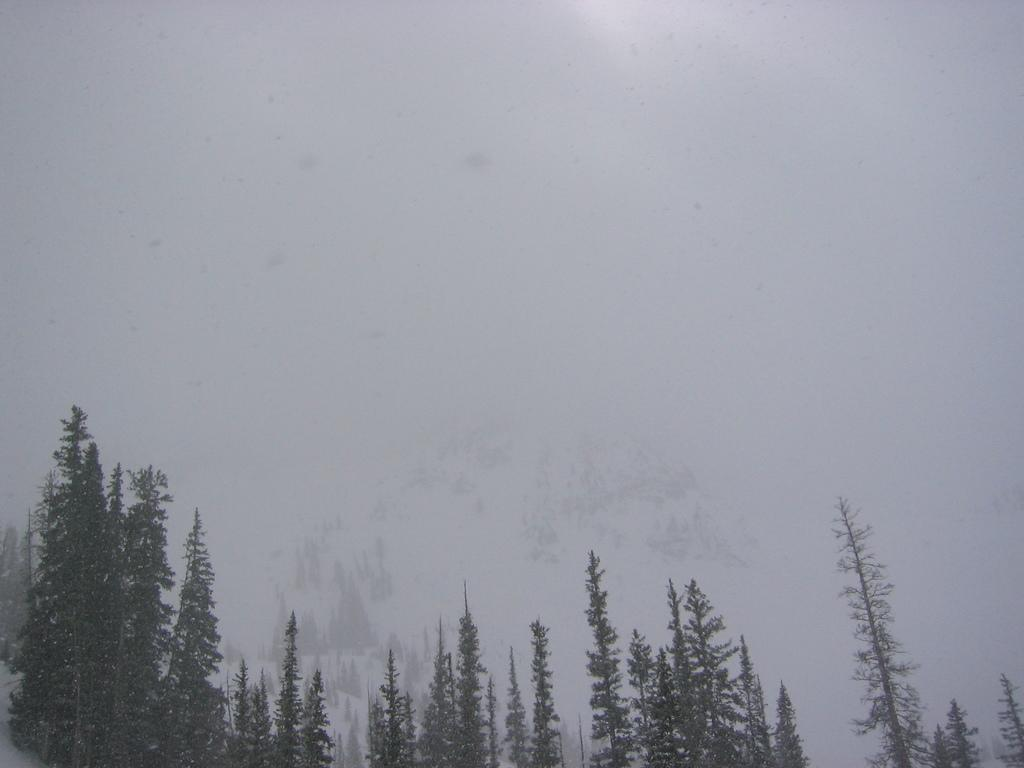What type of vegetation can be seen in the image? There are trees in the image. What is the weather like in the image? There is snow visible in the image, which suggests a cold or wintery environment. What type of underwear is hanging on the trees in the image? There is no underwear present in the image; it only features trees and snow. 